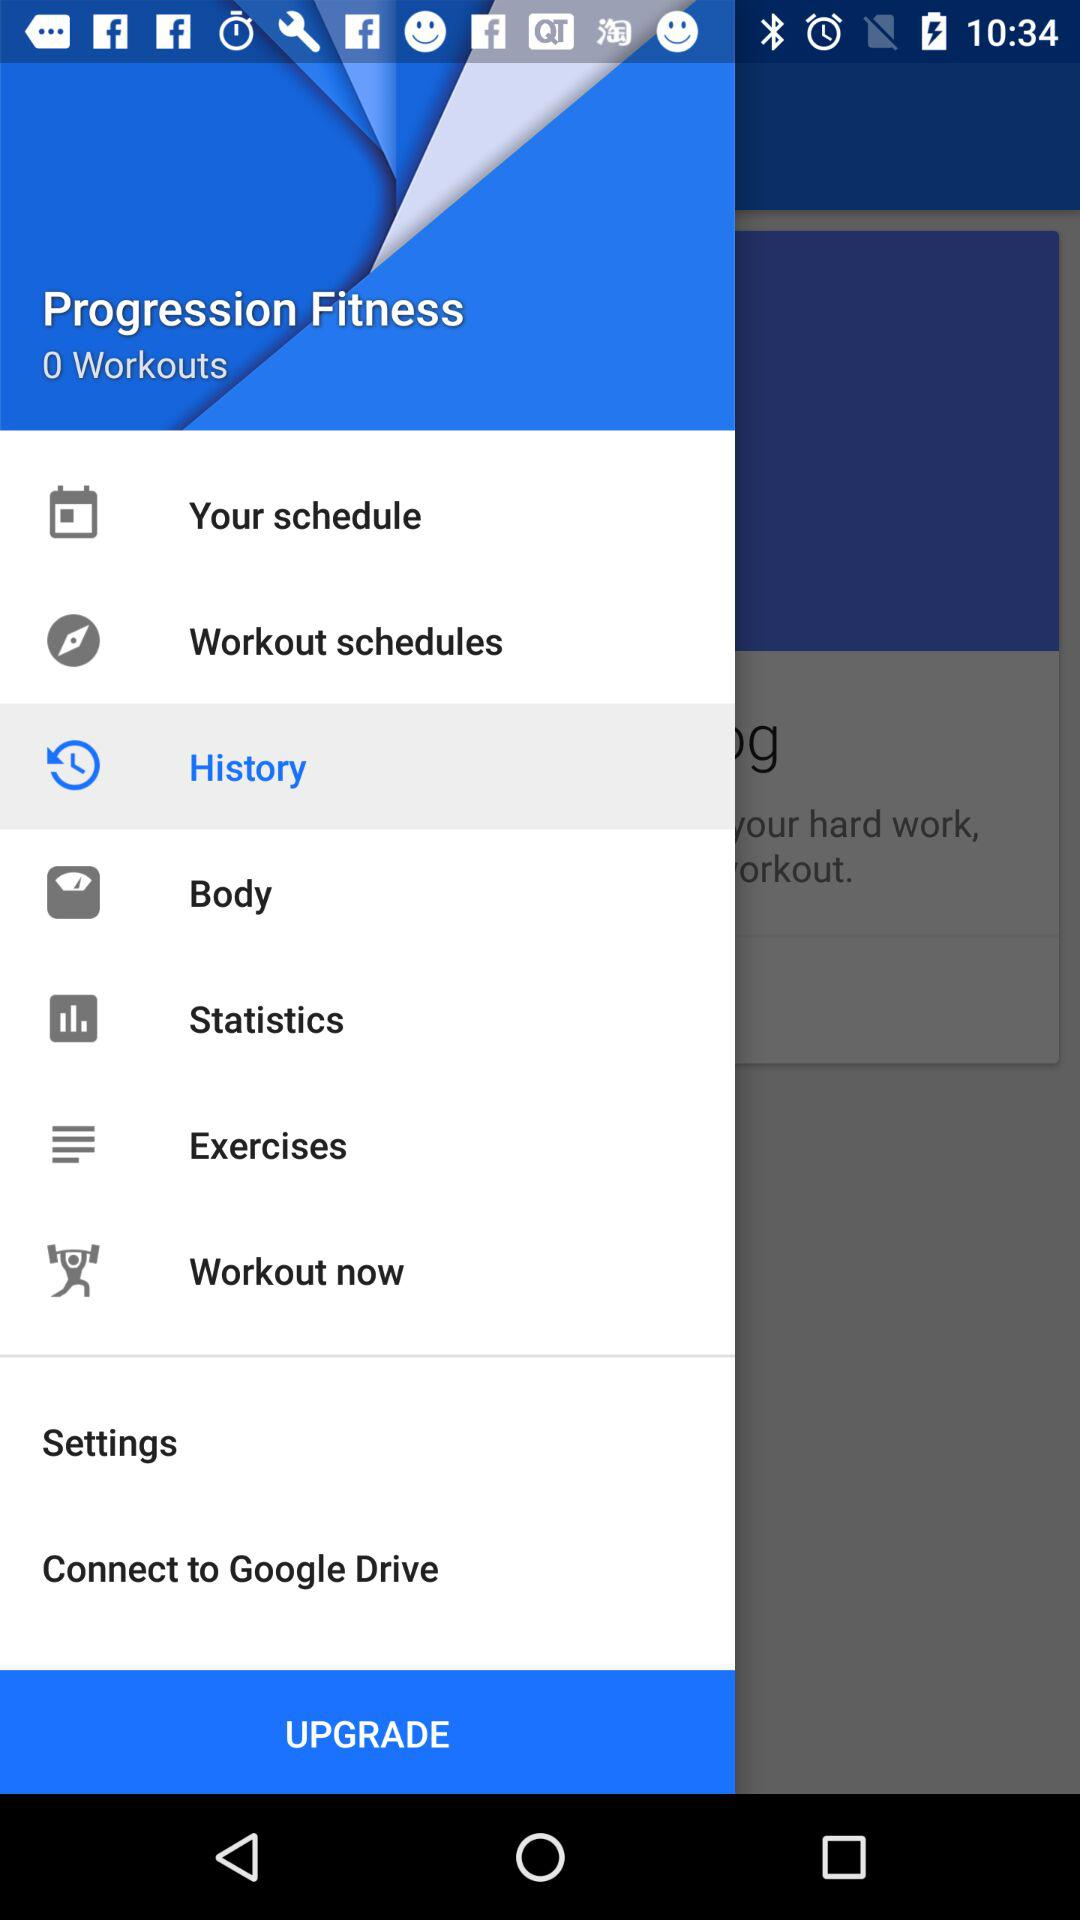What is the highlighted option? The highlighted option is "History". 